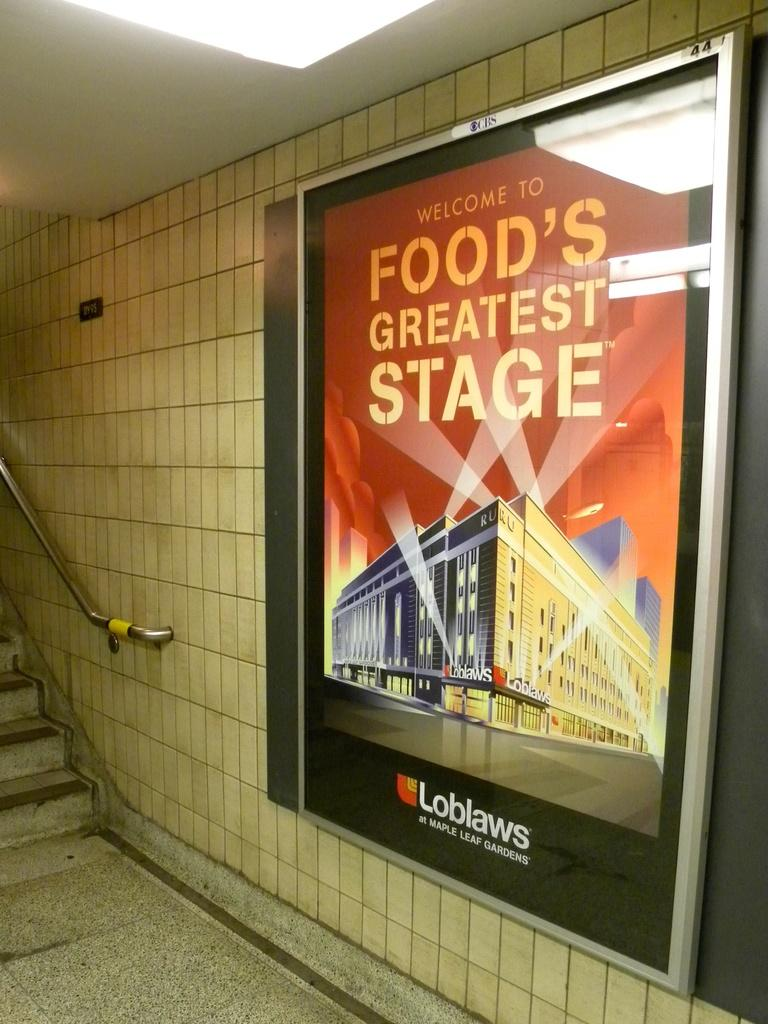<image>
Create a compact narrative representing the image presented. A poster of Loblaws placed by a stairs in a metro station. 